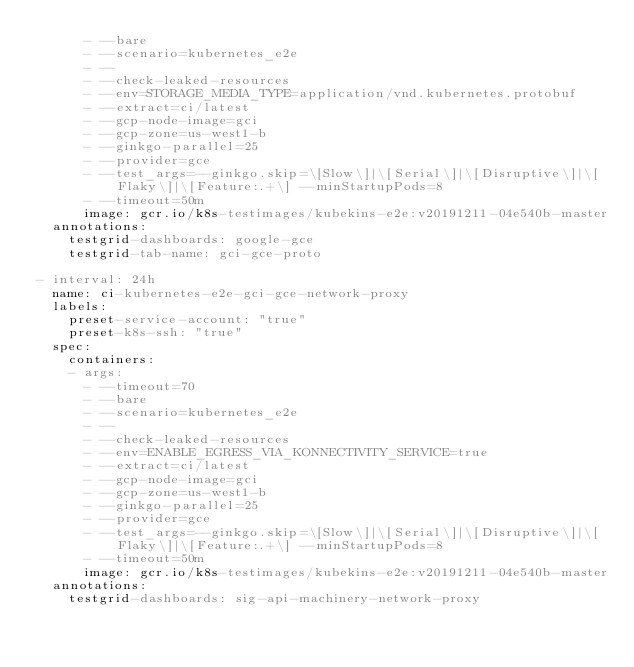<code> <loc_0><loc_0><loc_500><loc_500><_YAML_>      - --bare
      - --scenario=kubernetes_e2e
      - --
      - --check-leaked-resources
      - --env=STORAGE_MEDIA_TYPE=application/vnd.kubernetes.protobuf
      - --extract=ci/latest
      - --gcp-node-image=gci
      - --gcp-zone=us-west1-b
      - --ginkgo-parallel=25
      - --provider=gce
      - --test_args=--ginkgo.skip=\[Slow\]|\[Serial\]|\[Disruptive\]|\[Flaky\]|\[Feature:.+\] --minStartupPods=8
      - --timeout=50m
      image: gcr.io/k8s-testimages/kubekins-e2e:v20191211-04e540b-master
  annotations:
    testgrid-dashboards: google-gce
    testgrid-tab-name: gci-gce-proto

- interval: 24h
  name: ci-kubernetes-e2e-gci-gce-network-proxy
  labels:
    preset-service-account: "true"
    preset-k8s-ssh: "true"
  spec:
    containers:
    - args:
      - --timeout=70
      - --bare
      - --scenario=kubernetes_e2e
      - --
      - --check-leaked-resources
      - --env=ENABLE_EGRESS_VIA_KONNECTIVITY_SERVICE=true
      - --extract=ci/latest
      - --gcp-node-image=gci
      - --gcp-zone=us-west1-b
      - --ginkgo-parallel=25
      - --provider=gce
      - --test_args=--ginkgo.skip=\[Slow\]|\[Serial\]|\[Disruptive\]|\[Flaky\]|\[Feature:.+\] --minStartupPods=8
      - --timeout=50m
      image: gcr.io/k8s-testimages/kubekins-e2e:v20191211-04e540b-master
  annotations:
    testgrid-dashboards: sig-api-machinery-network-proxy
</code> 